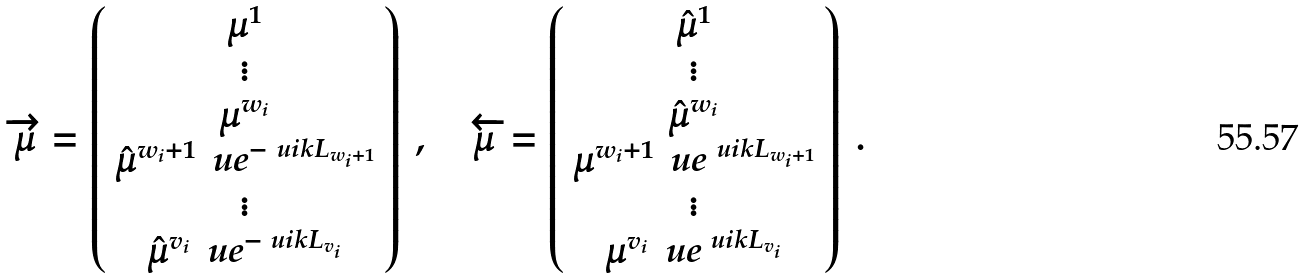<formula> <loc_0><loc_0><loc_500><loc_500>\overrightarrow { \mu } = \left ( \begin{array} { c } \mu ^ { 1 } \\ \vdots \\ \mu ^ { w _ { i } } \\ \hat { \mu } ^ { w _ { i } + 1 } \, \ u e ^ { - \ u i k L _ { w _ { i } + 1 } } \\ \vdots \\ \hat { \mu } ^ { v _ { i } } \, \ u e ^ { - \ u i k L _ { v _ { i } } } \end{array} \right ) \ , \quad \overleftarrow { \mu } = \left ( \begin{array} { c } \hat { \mu } ^ { 1 } \\ \vdots \\ \hat { \mu } ^ { w _ { i } } \\ \mu ^ { w _ { i } + 1 } \, \ u e ^ { \ u i k L _ { w _ { i } + 1 } } \\ \vdots \\ \mu ^ { v _ { i } } \, \ u e ^ { \ u i k L _ { v _ { i } } } \\ \end{array} \right ) \ .</formula> 